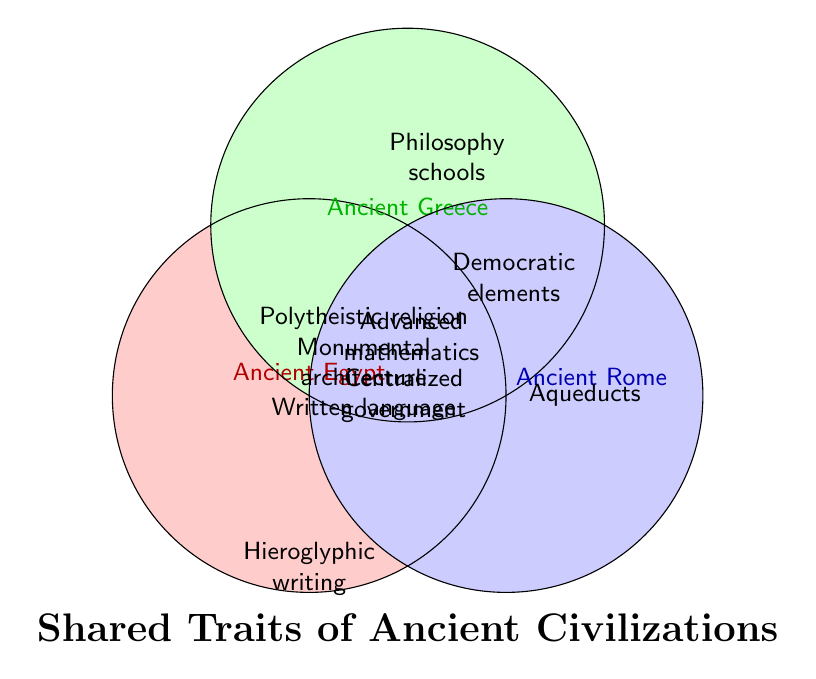What are the three shared traits of all three civilizations? The figure shows the overlapping area where all three circles intersect, listing the shared traits of Ancient Egypt, Ancient Greece, and Ancient Rome. These traits are Polytheistic religion, Monumental architecture, and Written language.
Answer: Polytheistic religion, Monumental architecture, Written language Which civilization has a trait not shared with the other two civilizations? Ancient Egypt has the trait of Hieroglyphic writing, Ancient Greece has the trait of Philosophy schools, and Ancient Rome has the trait of Aqueducts. These traits are not shared with the other two civilizations.
Answer: Ancient Egypt, Ancient Greece, Ancient Rome Which two civilizations share the trait of Centralized government? The figure shows that Centralized government is in the intersection area between Ancient Egypt and Ancient Rome only.
Answer: Ancient Egypt and Ancient Rome What trait is unique to Ancient Greece in the figure? Within the Ancient Greece circle, only Philosophy schools do not overlap with the other civilizations.
Answer: Philosophy schools Describe a shared trait of Ancient Greece and Ancient Rome but not Ancient Egypt? The trait Democratic elements is in the intersection area between Ancient Greece and Ancient Rome but is not overlapping with Ancient Egypt.
Answer: Democratic elements How many unique traits does Ancient Egypt have that are not shared with the other two civilizations? The figure shows one trait in the Ancient Egypt circle that does not overlap with Ancient Greece or Ancient Rome, which is Hieroglyphic writing.
Answer: One Are there more traits shared by all three civilizations or unique traits within individual civilizations? Three shared traits are found in the center of the Venn Diagram (Polytheistic religion, Monumental architecture, Written language), while there are three unique traits, one per civilization (Hieroglyphic writing, Philosophy schools, Aqueducts). The number of shared traits is equal to the number of unique traits.
Answer: Equal What is the relationship between the traits Advanced mathematics and Democratic elements? Advanced mathematics is shared between Ancient Egypt and Ancient Greece, while Democratic elements are shared between Ancient Greece and Ancient Rome. These two traits are not directly related in the figure.
Answer: No direct relationship Which civilization does not have any traits shared exclusively with another single civilization? Ancient Greece does not have any traits that are shared exclusively with only one other civilization. All traits of Ancient Greece are either unique or shared with both other civilizations.
Answer: Ancient Greece 